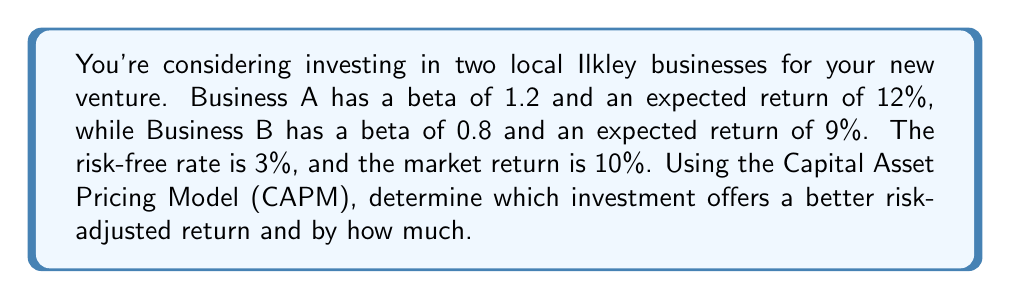Give your solution to this math problem. To solve this problem, we'll use the Capital Asset Pricing Model (CAPM) formula:

$$ E(R_i) = R_f + \beta_i(R_m - R_f) $$

Where:
$E(R_i)$ = Expected return of the asset
$R_f$ = Risk-free rate
$\beta_i$ = Beta of the asset
$R_m$ = Market return

Given:
$R_f = 3\%$
$R_m = 10\%$

Step 1: Calculate the expected return for Business A using CAPM
$$ E(R_A) = 3\% + 1.2(10\% - 3\%) = 3\% + 1.2(7\%) = 3\% + 8.4\% = 11.4\% $$

Step 2: Calculate the expected return for Business B using CAPM
$$ E(R_B) = 3\% + 0.8(10\% - 3\%) = 3\% + 0.8(7\%) = 3\% + 5.6\% = 8.6\% $$

Step 3: Compare the CAPM expected returns with the given expected returns

Business A:
CAPM expected return: 11.4%
Given expected return: 12%
Difference: 12% - 11.4% = 0.6%

Business B:
CAPM expected return: 8.6%
Given expected return: 9%
Difference: 9% - 8.6% = 0.4%

Step 4: Determine which investment offers a better risk-adjusted return

Business A offers a 0.6% higher return than what CAPM predicts, while Business B offers a 0.4% higher return than what CAPM predicts. Therefore, Business A offers a better risk-adjusted return.

Step 5: Calculate the difference in risk-adjusted return
0.6% - 0.4% = 0.2%
Answer: Business A offers a better risk-adjusted return by 0.2% compared to Business B. 